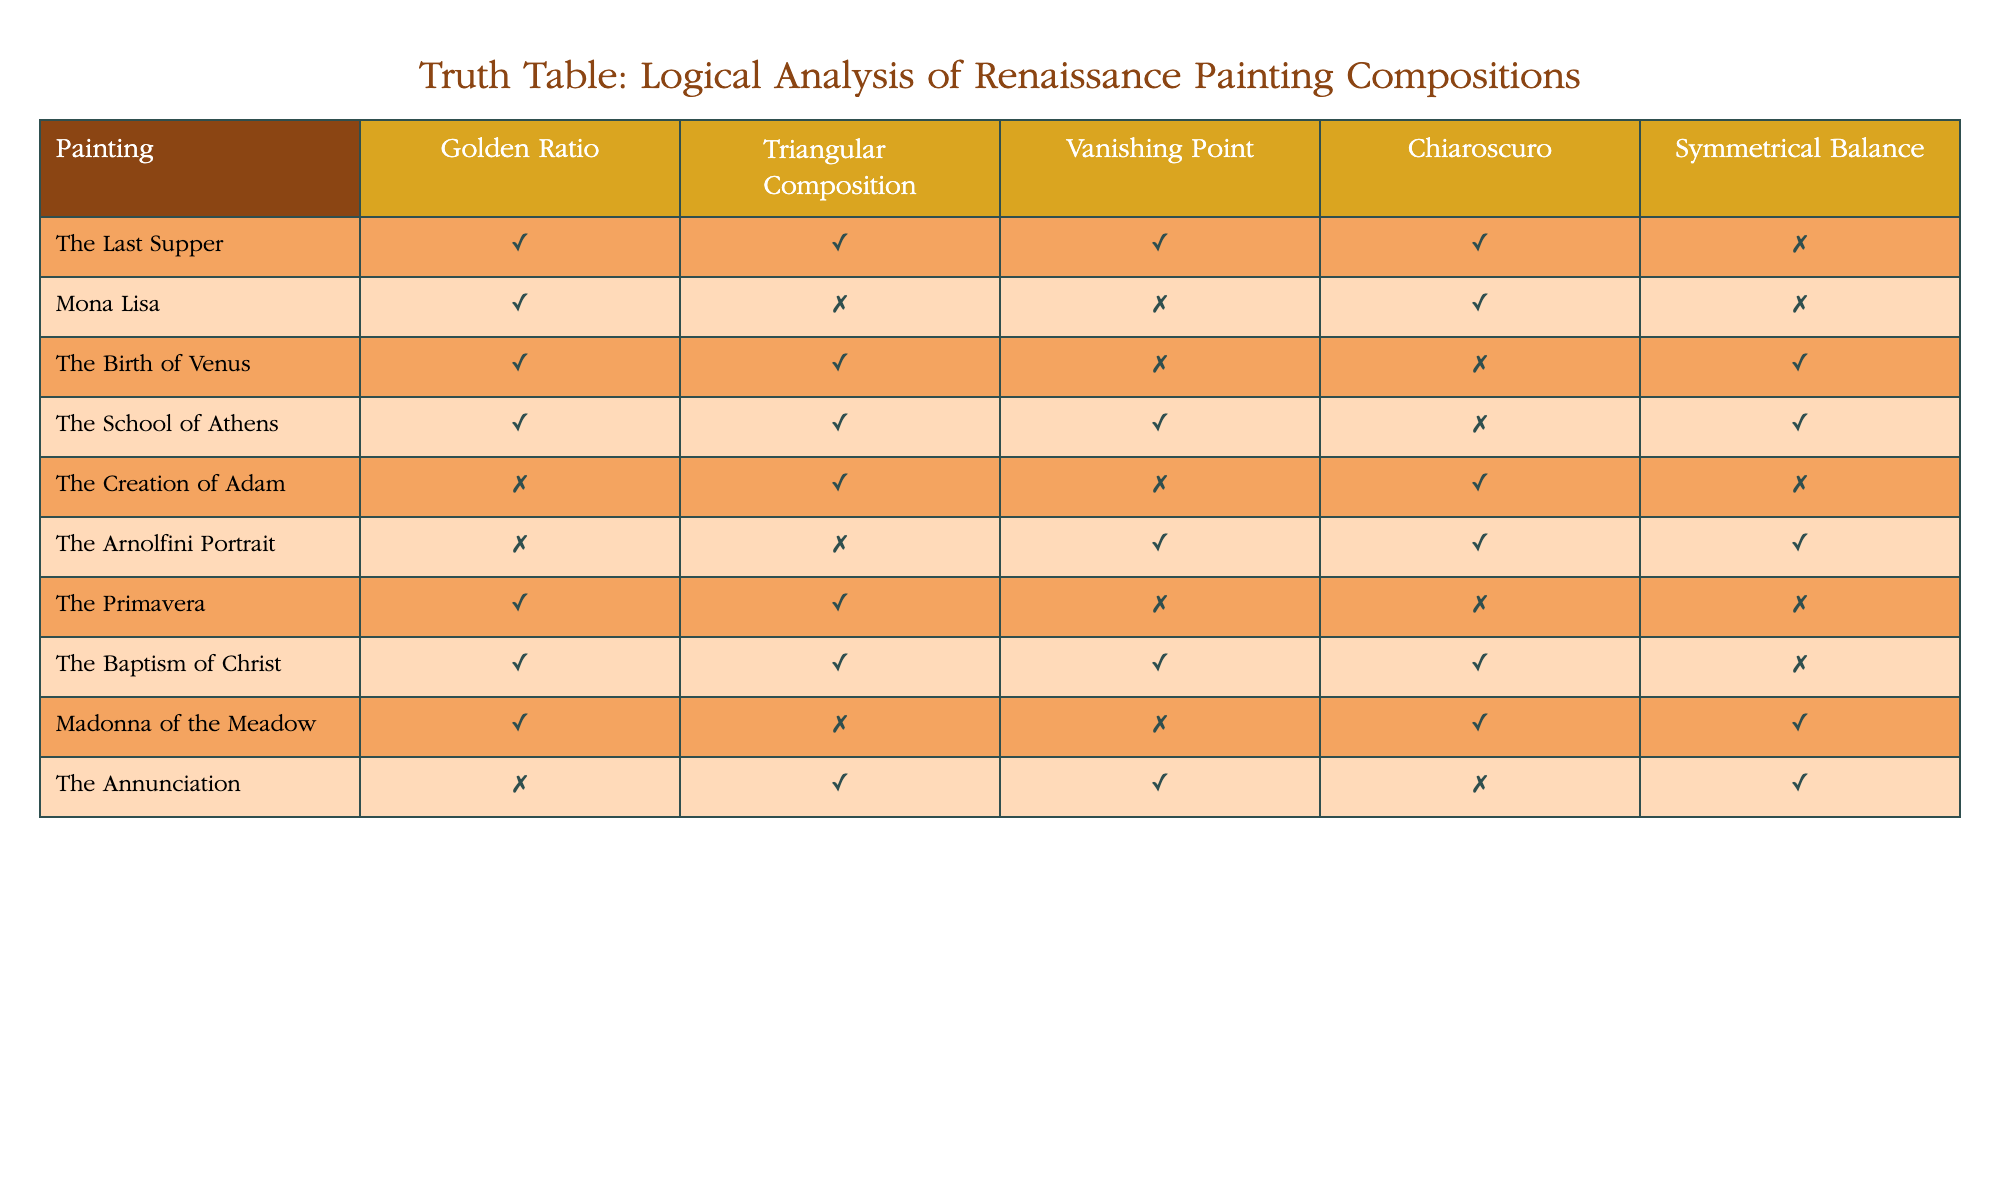What is the name of the painting that features both the Golden Ratio and Triangular Composition? By looking at the table, I can see that both the "Golden Ratio" and "Triangular Composition" columns have a value of TRUE for "The Birth of Venus" and "The School of Athens". However, "The School of Athens" also has TRUE in the "Vanishing Point" column, making it special. Thus, I will select "The School of Athens" for featuring both the Golden Ratio and Triangular Composition distinctly.
Answer: The School of Athens How many paintings utilize Chiaroscuro? Reviewing the "Chiaroscuro" column, I can count the TRUE entries. They are found in "The Last Supper", "Mona Lisa", "The Creation of Adam", "The Arnolfini Portrait", and "Madonna of the Meadow", which totals to 5.
Answer: 5 Which painting does not exhibit Symmetrical Balance? Inspecting the "Symmetrical Balance" column, the paintings where this attribute is FALSE are "The Last Supper", "The Birth of Venus", "The Primavera", and "The Baptism of Christ". Amongst these, "The Last Supper" is the first listed one.
Answer: The Last Supper What fraction of the paintings have both Golden Ratio and Triangular Composition? There are a total of 10 paintings, and the ones that have both TRUE in the respective columns are "The Last Supper", "The Birth of Venus", "The School of Athens", and "The Baptism of Christ", which totals 4. Thus, the fraction is 4 out of 10, or 4/10, which simplifies to 2/5.
Answer: 2/5 Is "The Creation of Adam" using the Golden Ratio? Looking at the "Golden Ratio" column for "The Creation of Adam", I see that the value is FALSE. Thus, the painting does not use the Golden Ratio.
Answer: No Which painting has the least attributes marked TRUE? Analyzing the rows, I see that both "The Arnolfini Portrait" and "The Creation of Adam" each have 3 attributes marked TRUE. However, "The Arnolfini Portrait" holds TRUE for both "Vanishing Point" and "Chiaroscuro", and has a balanced representation with 3 TRUEs. Thus, it stands equally with "The Creation of Adam", which highlights the limitation of TRUE attributes, leaving it ambiguous in determining which holds the least.
Answer: The Creation of Adam and The Arnolfini Portrait How many paintings exhibit both Chiaroscuro and Vanishing Point? Inspecting the columns for Chiaroscuro and Vanishing Point, I find that "The Last Supper", "The School of Athens", "The Baptism of Christ", and "The Annunciation" all show TRUE in both columns. This gives a total of 4 paintings.
Answer: 4 What is the relationship between Triangular Composition and Symmetrical Balance for "The Birth of Venus"? For "The Birth of Venus", the values are TRUE for Triangular Composition and TRUE for Symmetrical Balance. This indicates that the painting integrates both compositional techniques successfully, suggesting a harmonious design.
Answer: Both TRUE Are there any paintings that feature all five attributes as TRUE? Analyzing the table, none of the paintings possess all five attributes marked as TRUE. Throughout the dataset, the maximum observed is three TRUE attributes, thus validating the absence of any that meet all criteria.
Answer: No 